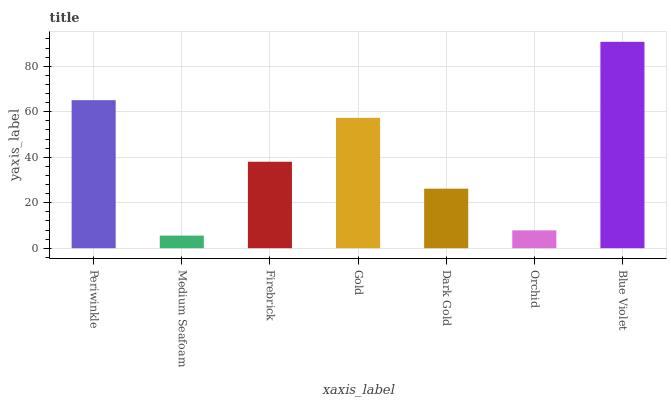Is Firebrick the minimum?
Answer yes or no. No. Is Firebrick the maximum?
Answer yes or no. No. Is Firebrick greater than Medium Seafoam?
Answer yes or no. Yes. Is Medium Seafoam less than Firebrick?
Answer yes or no. Yes. Is Medium Seafoam greater than Firebrick?
Answer yes or no. No. Is Firebrick less than Medium Seafoam?
Answer yes or no. No. Is Firebrick the high median?
Answer yes or no. Yes. Is Firebrick the low median?
Answer yes or no. Yes. Is Orchid the high median?
Answer yes or no. No. Is Medium Seafoam the low median?
Answer yes or no. No. 